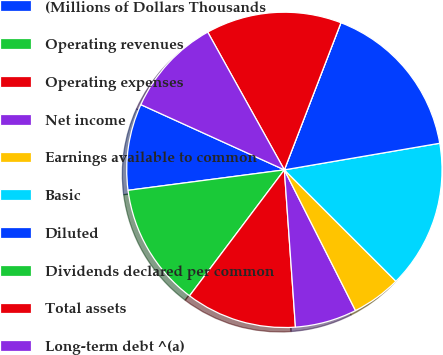Convert chart. <chart><loc_0><loc_0><loc_500><loc_500><pie_chart><fcel>(Millions of Dollars Thousands<fcel>Operating revenues<fcel>Operating expenses<fcel>Net income<fcel>Earnings available to common<fcel>Basic<fcel>Diluted<fcel>Dividends declared per common<fcel>Total assets<fcel>Long-term debt ^(a)<nl><fcel>8.86%<fcel>12.66%<fcel>11.39%<fcel>6.33%<fcel>5.06%<fcel>15.19%<fcel>16.46%<fcel>0.0%<fcel>13.92%<fcel>10.13%<nl></chart> 